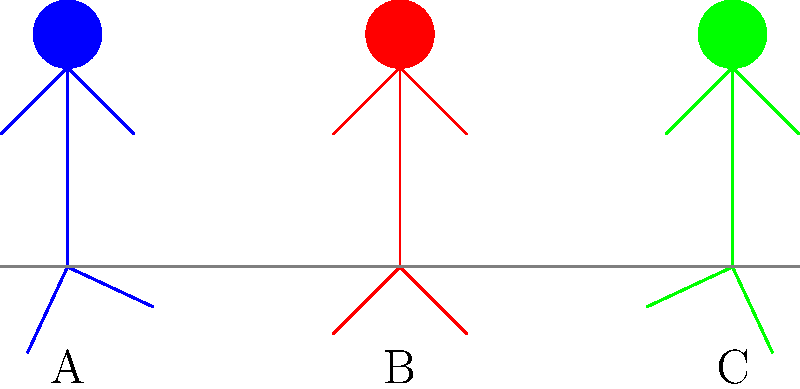During an international summit, three world leaders are observed walking side by side. Their gait patterns are represented by the stick figures A, B, and C in the diagram. Based on your knowledge of biomechanics and political body language, which leader is likely projecting the most confidence and authority through their walking style? To analyze the gait patterns and determine which leader projects the most confidence and authority, we need to consider several biomechanical factors:

1. Posture: An upright posture indicates confidence and authority.
2. Stride length: A longer stride is often associated with confidence and purposefulness.
3. Arm swing: A balanced, controlled arm swing can project authority.
4. Symmetry: A symmetrical gait pattern suggests stability and control.

Analyzing each figure:

A (Blue):
- Leaning slightly forward
- Wider stance
- Asymmetrical arm positions

B (Red):
- Upright posture
- Symmetrical arm and leg positions
- Balanced stance

C (Green):
- Leaning slightly backward
- Narrower stance
- Asymmetrical arm positions

Based on these observations, Figure B (Red) displays the most confident and authoritative gait pattern. The upright posture, symmetrical arm and leg positions, and balanced stance all contribute to projecting confidence and authority.

In political science, body language and non-verbal communication play crucial roles in how leaders are perceived. An authoritative and confident gait can influence public perception and potentially impact diplomatic interactions.
Answer: B (Red) 